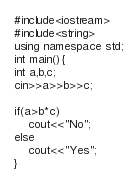Convert code to text. <code><loc_0><loc_0><loc_500><loc_500><_C++_>
#include<iostream>
#include<string>
using namespace std;
int main(){
int a,b,c;
cin>>a>>b>>c;

if(a>b*c)
	cout<<"No";
else
	cout<<"Yes";
}
</code> 